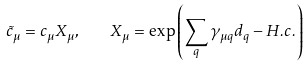<formula> <loc_0><loc_0><loc_500><loc_500>\tilde { c } _ { \mu } = c _ { \mu } X _ { \mu } , \quad X _ { \mu } = \exp \left ( \sum _ { q } \gamma _ { \mu q } d _ { q } - H . c . \right )</formula> 